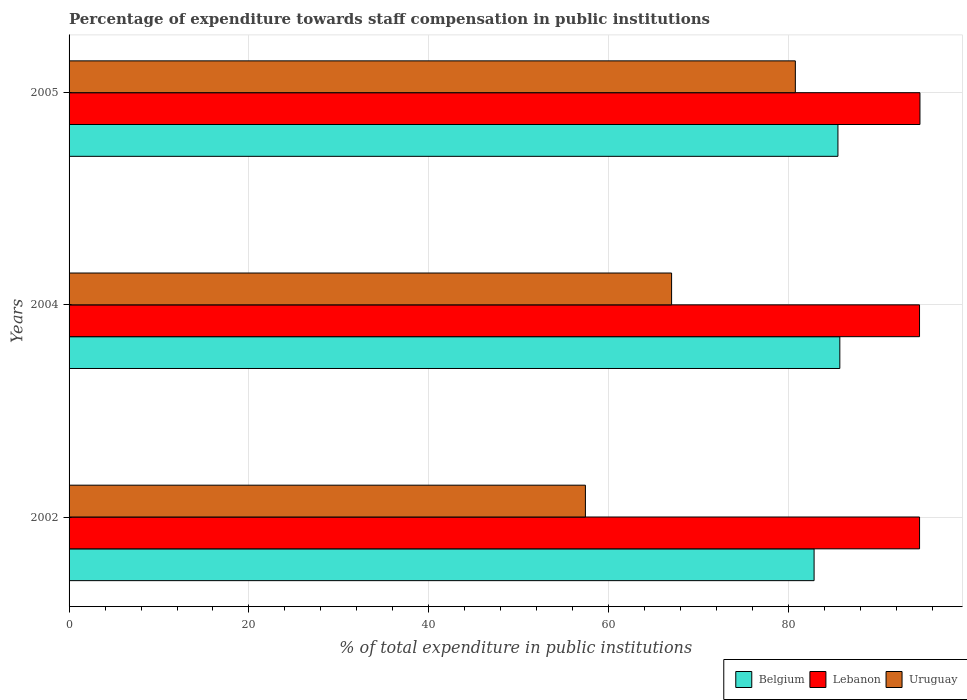How many groups of bars are there?
Provide a short and direct response. 3. Are the number of bars per tick equal to the number of legend labels?
Offer a very short reply. Yes. What is the label of the 1st group of bars from the top?
Provide a short and direct response. 2005. What is the percentage of expenditure towards staff compensation in Belgium in 2004?
Offer a terse response. 85.7. Across all years, what is the maximum percentage of expenditure towards staff compensation in Uruguay?
Your answer should be very brief. 80.75. Across all years, what is the minimum percentage of expenditure towards staff compensation in Belgium?
Offer a terse response. 82.83. In which year was the percentage of expenditure towards staff compensation in Belgium maximum?
Your response must be concise. 2004. In which year was the percentage of expenditure towards staff compensation in Lebanon minimum?
Your response must be concise. 2004. What is the total percentage of expenditure towards staff compensation in Belgium in the graph?
Offer a terse response. 254.02. What is the difference between the percentage of expenditure towards staff compensation in Uruguay in 2002 and that in 2004?
Provide a succinct answer. -9.58. What is the difference between the percentage of expenditure towards staff compensation in Uruguay in 2004 and the percentage of expenditure towards staff compensation in Belgium in 2005?
Ensure brevity in your answer.  -18.5. What is the average percentage of expenditure towards staff compensation in Uruguay per year?
Offer a terse response. 68.38. In the year 2004, what is the difference between the percentage of expenditure towards staff compensation in Belgium and percentage of expenditure towards staff compensation in Uruguay?
Keep it short and to the point. 18.7. In how many years, is the percentage of expenditure towards staff compensation in Belgium greater than 20 %?
Give a very brief answer. 3. What is the ratio of the percentage of expenditure towards staff compensation in Belgium in 2002 to that in 2004?
Offer a terse response. 0.97. What is the difference between the highest and the second highest percentage of expenditure towards staff compensation in Uruguay?
Your response must be concise. 13.76. What is the difference between the highest and the lowest percentage of expenditure towards staff compensation in Belgium?
Your answer should be compact. 2.86. Is the sum of the percentage of expenditure towards staff compensation in Lebanon in 2002 and 2005 greater than the maximum percentage of expenditure towards staff compensation in Belgium across all years?
Your response must be concise. Yes. What does the 1st bar from the top in 2004 represents?
Offer a very short reply. Uruguay. What does the 3rd bar from the bottom in 2005 represents?
Make the answer very short. Uruguay. How many years are there in the graph?
Give a very brief answer. 3. Does the graph contain any zero values?
Ensure brevity in your answer.  No. Does the graph contain grids?
Give a very brief answer. Yes. Where does the legend appear in the graph?
Your answer should be compact. Bottom right. What is the title of the graph?
Ensure brevity in your answer.  Percentage of expenditure towards staff compensation in public institutions. Does "Haiti" appear as one of the legend labels in the graph?
Offer a very short reply. No. What is the label or title of the X-axis?
Offer a terse response. % of total expenditure in public institutions. What is the % of total expenditure in public institutions of Belgium in 2002?
Offer a terse response. 82.83. What is the % of total expenditure in public institutions of Lebanon in 2002?
Provide a succinct answer. 94.56. What is the % of total expenditure in public institutions in Uruguay in 2002?
Your response must be concise. 57.41. What is the % of total expenditure in public institutions of Belgium in 2004?
Offer a very short reply. 85.7. What is the % of total expenditure in public institutions of Lebanon in 2004?
Your answer should be compact. 94.56. What is the % of total expenditure in public institutions in Uruguay in 2004?
Provide a succinct answer. 66.99. What is the % of total expenditure in public institutions in Belgium in 2005?
Keep it short and to the point. 85.49. What is the % of total expenditure in public institutions in Lebanon in 2005?
Provide a succinct answer. 94.6. What is the % of total expenditure in public institutions in Uruguay in 2005?
Offer a terse response. 80.75. Across all years, what is the maximum % of total expenditure in public institutions in Belgium?
Provide a succinct answer. 85.7. Across all years, what is the maximum % of total expenditure in public institutions of Lebanon?
Provide a short and direct response. 94.6. Across all years, what is the maximum % of total expenditure in public institutions in Uruguay?
Your answer should be compact. 80.75. Across all years, what is the minimum % of total expenditure in public institutions in Belgium?
Make the answer very short. 82.83. Across all years, what is the minimum % of total expenditure in public institutions of Lebanon?
Provide a short and direct response. 94.56. Across all years, what is the minimum % of total expenditure in public institutions in Uruguay?
Make the answer very short. 57.41. What is the total % of total expenditure in public institutions in Belgium in the graph?
Ensure brevity in your answer.  254.02. What is the total % of total expenditure in public institutions in Lebanon in the graph?
Keep it short and to the point. 283.73. What is the total % of total expenditure in public institutions of Uruguay in the graph?
Give a very brief answer. 205.15. What is the difference between the % of total expenditure in public institutions of Belgium in 2002 and that in 2004?
Keep it short and to the point. -2.86. What is the difference between the % of total expenditure in public institutions of Lebanon in 2002 and that in 2004?
Your answer should be very brief. 0. What is the difference between the % of total expenditure in public institutions in Uruguay in 2002 and that in 2004?
Offer a terse response. -9.58. What is the difference between the % of total expenditure in public institutions of Belgium in 2002 and that in 2005?
Provide a short and direct response. -2.65. What is the difference between the % of total expenditure in public institutions of Lebanon in 2002 and that in 2005?
Keep it short and to the point. -0.04. What is the difference between the % of total expenditure in public institutions in Uruguay in 2002 and that in 2005?
Give a very brief answer. -23.34. What is the difference between the % of total expenditure in public institutions in Belgium in 2004 and that in 2005?
Offer a very short reply. 0.21. What is the difference between the % of total expenditure in public institutions in Lebanon in 2004 and that in 2005?
Your answer should be very brief. -0.05. What is the difference between the % of total expenditure in public institutions in Uruguay in 2004 and that in 2005?
Your answer should be very brief. -13.76. What is the difference between the % of total expenditure in public institutions in Belgium in 2002 and the % of total expenditure in public institutions in Lebanon in 2004?
Keep it short and to the point. -11.72. What is the difference between the % of total expenditure in public institutions in Belgium in 2002 and the % of total expenditure in public institutions in Uruguay in 2004?
Provide a short and direct response. 15.84. What is the difference between the % of total expenditure in public institutions of Lebanon in 2002 and the % of total expenditure in public institutions of Uruguay in 2004?
Keep it short and to the point. 27.57. What is the difference between the % of total expenditure in public institutions of Belgium in 2002 and the % of total expenditure in public institutions of Lebanon in 2005?
Your answer should be very brief. -11.77. What is the difference between the % of total expenditure in public institutions of Belgium in 2002 and the % of total expenditure in public institutions of Uruguay in 2005?
Offer a very short reply. 2.08. What is the difference between the % of total expenditure in public institutions of Lebanon in 2002 and the % of total expenditure in public institutions of Uruguay in 2005?
Make the answer very short. 13.81. What is the difference between the % of total expenditure in public institutions of Belgium in 2004 and the % of total expenditure in public institutions of Lebanon in 2005?
Ensure brevity in your answer.  -8.91. What is the difference between the % of total expenditure in public institutions of Belgium in 2004 and the % of total expenditure in public institutions of Uruguay in 2005?
Keep it short and to the point. 4.95. What is the difference between the % of total expenditure in public institutions in Lebanon in 2004 and the % of total expenditure in public institutions in Uruguay in 2005?
Offer a terse response. 13.81. What is the average % of total expenditure in public institutions of Belgium per year?
Your answer should be very brief. 84.67. What is the average % of total expenditure in public institutions in Lebanon per year?
Provide a short and direct response. 94.58. What is the average % of total expenditure in public institutions in Uruguay per year?
Offer a very short reply. 68.38. In the year 2002, what is the difference between the % of total expenditure in public institutions of Belgium and % of total expenditure in public institutions of Lebanon?
Give a very brief answer. -11.73. In the year 2002, what is the difference between the % of total expenditure in public institutions of Belgium and % of total expenditure in public institutions of Uruguay?
Provide a succinct answer. 25.43. In the year 2002, what is the difference between the % of total expenditure in public institutions in Lebanon and % of total expenditure in public institutions in Uruguay?
Provide a short and direct response. 37.15. In the year 2004, what is the difference between the % of total expenditure in public institutions in Belgium and % of total expenditure in public institutions in Lebanon?
Your answer should be compact. -8.86. In the year 2004, what is the difference between the % of total expenditure in public institutions in Belgium and % of total expenditure in public institutions in Uruguay?
Provide a succinct answer. 18.7. In the year 2004, what is the difference between the % of total expenditure in public institutions of Lebanon and % of total expenditure in public institutions of Uruguay?
Give a very brief answer. 27.57. In the year 2005, what is the difference between the % of total expenditure in public institutions in Belgium and % of total expenditure in public institutions in Lebanon?
Provide a succinct answer. -9.12. In the year 2005, what is the difference between the % of total expenditure in public institutions in Belgium and % of total expenditure in public institutions in Uruguay?
Provide a succinct answer. 4.74. In the year 2005, what is the difference between the % of total expenditure in public institutions of Lebanon and % of total expenditure in public institutions of Uruguay?
Provide a succinct answer. 13.85. What is the ratio of the % of total expenditure in public institutions of Belgium in 2002 to that in 2004?
Make the answer very short. 0.97. What is the ratio of the % of total expenditure in public institutions of Lebanon in 2002 to that in 2004?
Make the answer very short. 1. What is the ratio of the % of total expenditure in public institutions of Uruguay in 2002 to that in 2004?
Provide a short and direct response. 0.86. What is the ratio of the % of total expenditure in public institutions in Belgium in 2002 to that in 2005?
Ensure brevity in your answer.  0.97. What is the ratio of the % of total expenditure in public institutions in Uruguay in 2002 to that in 2005?
Ensure brevity in your answer.  0.71. What is the ratio of the % of total expenditure in public institutions in Belgium in 2004 to that in 2005?
Offer a very short reply. 1. What is the ratio of the % of total expenditure in public institutions in Uruguay in 2004 to that in 2005?
Give a very brief answer. 0.83. What is the difference between the highest and the second highest % of total expenditure in public institutions of Belgium?
Offer a terse response. 0.21. What is the difference between the highest and the second highest % of total expenditure in public institutions in Lebanon?
Your answer should be compact. 0.04. What is the difference between the highest and the second highest % of total expenditure in public institutions in Uruguay?
Your response must be concise. 13.76. What is the difference between the highest and the lowest % of total expenditure in public institutions of Belgium?
Offer a terse response. 2.86. What is the difference between the highest and the lowest % of total expenditure in public institutions in Lebanon?
Offer a very short reply. 0.05. What is the difference between the highest and the lowest % of total expenditure in public institutions of Uruguay?
Ensure brevity in your answer.  23.34. 